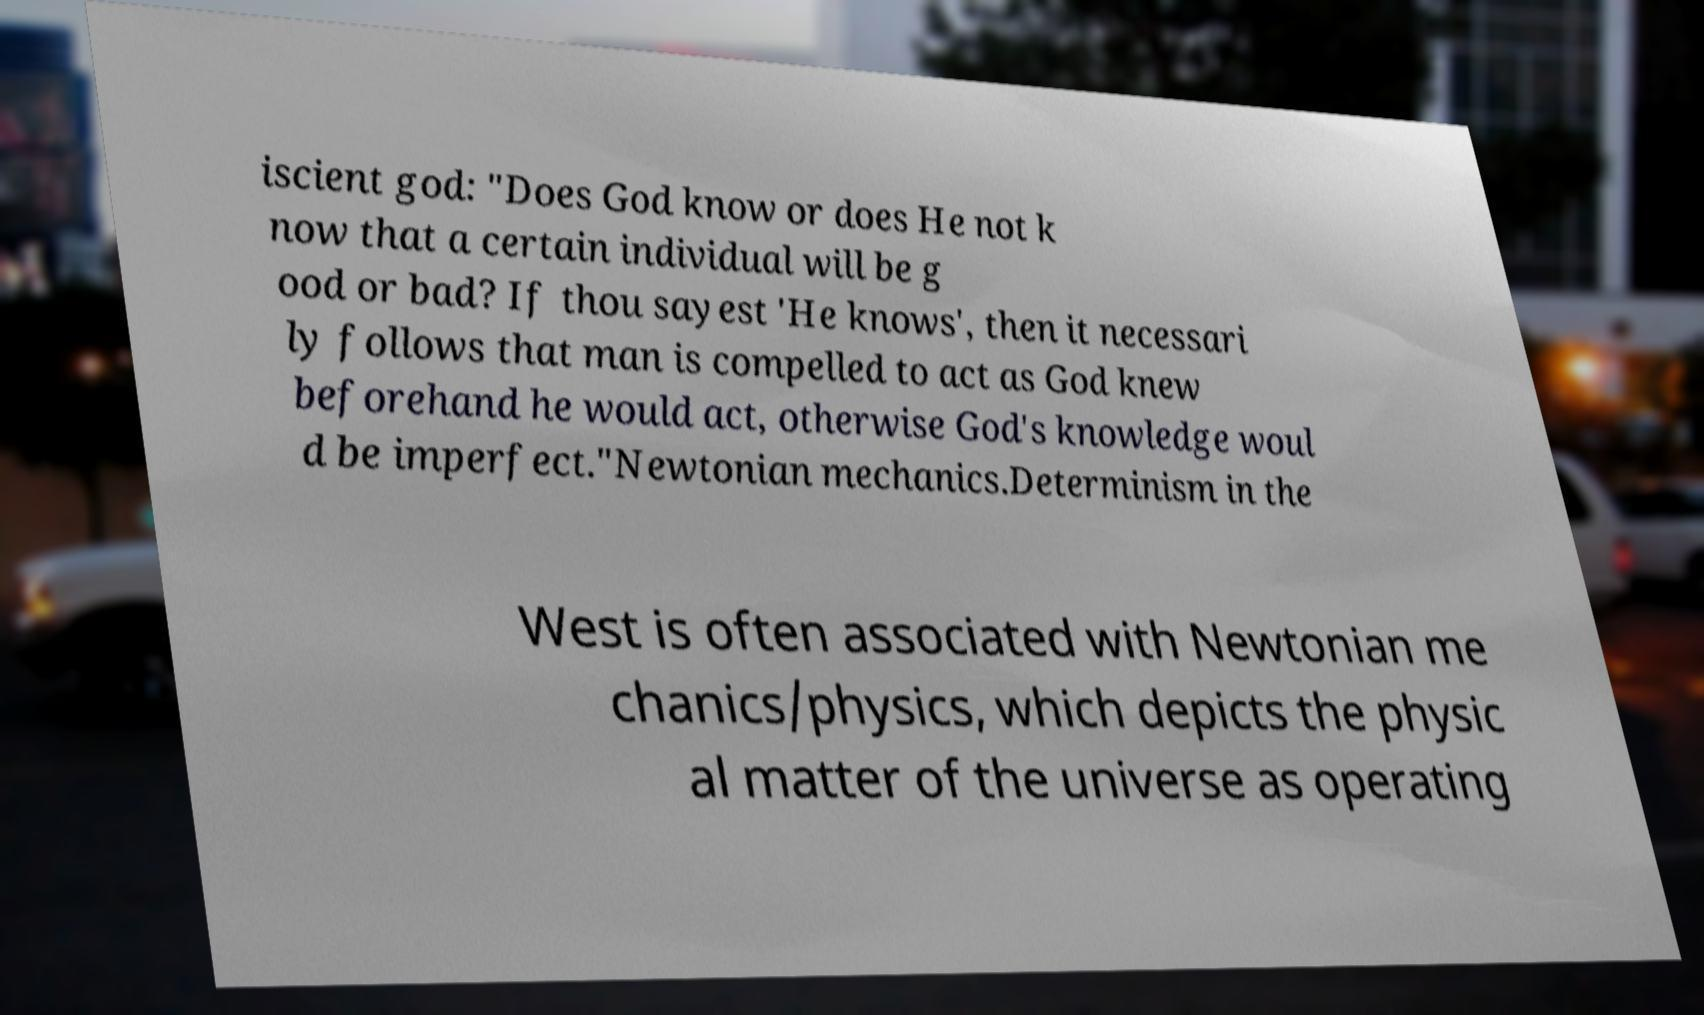Can you accurately transcribe the text from the provided image for me? iscient god: "Does God know or does He not k now that a certain individual will be g ood or bad? If thou sayest 'He knows', then it necessari ly follows that man is compelled to act as God knew beforehand he would act, otherwise God's knowledge woul d be imperfect."Newtonian mechanics.Determinism in the West is often associated with Newtonian me chanics/physics, which depicts the physic al matter of the universe as operating 